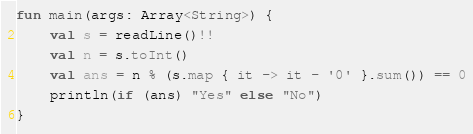<code> <loc_0><loc_0><loc_500><loc_500><_Kotlin_>fun main(args: Array<String>) {
    val s = readLine()!!
    val n = s.toInt()
    val ans = n % (s.map { it -> it - '0' }.sum()) == 0
    println(if (ans) "Yes" else "No")
}</code> 